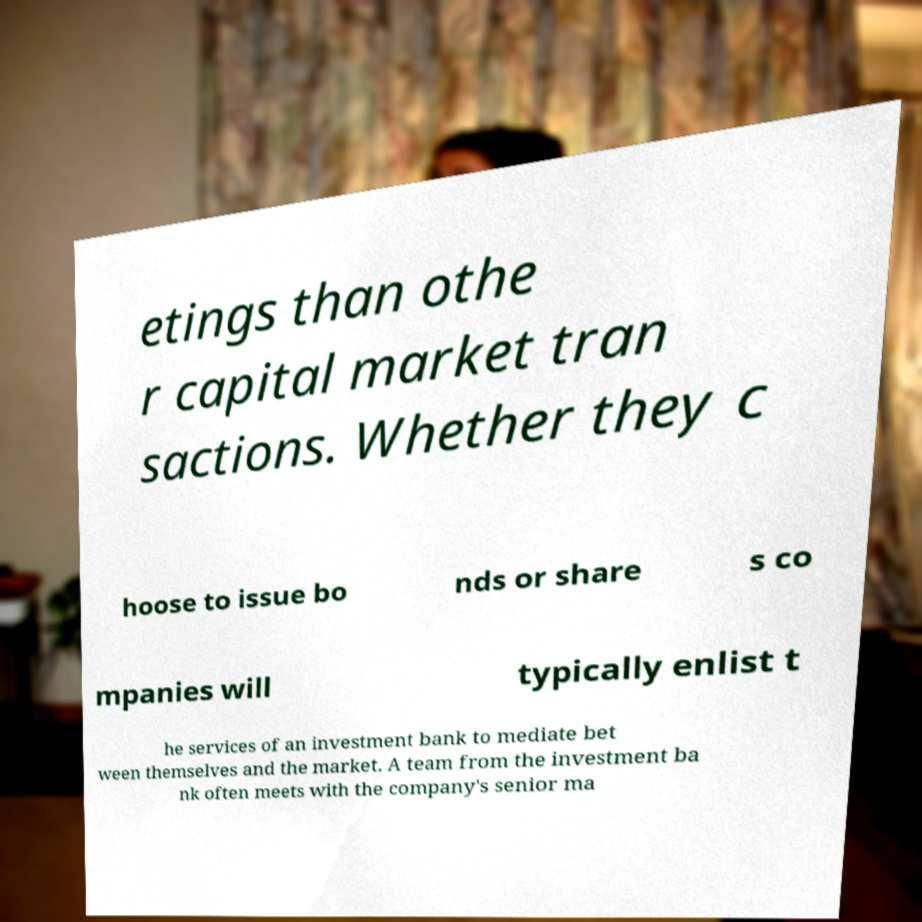Please read and relay the text visible in this image. What does it say? etings than othe r capital market tran sactions. Whether they c hoose to issue bo nds or share s co mpanies will typically enlist t he services of an investment bank to mediate bet ween themselves and the market. A team from the investment ba nk often meets with the company's senior ma 